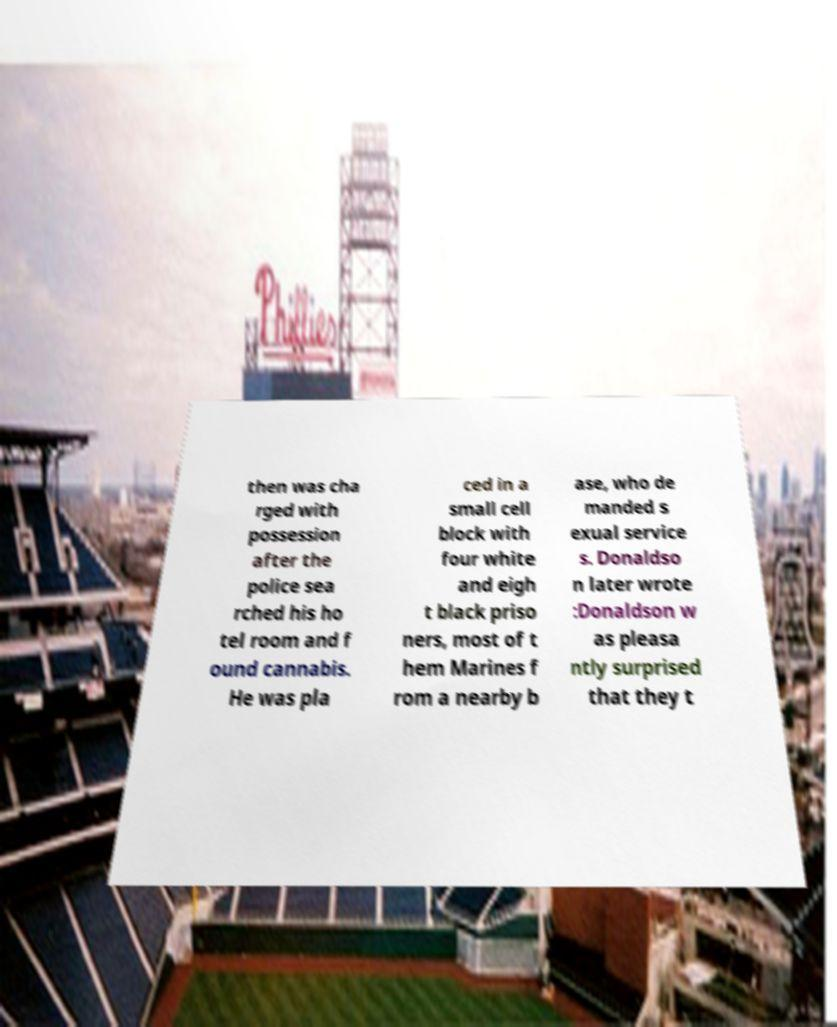Can you accurately transcribe the text from the provided image for me? then was cha rged with possession after the police sea rched his ho tel room and f ound cannabis. He was pla ced in a small cell block with four white and eigh t black priso ners, most of t hem Marines f rom a nearby b ase, who de manded s exual service s. Donaldso n later wrote :Donaldson w as pleasa ntly surprised that they t 